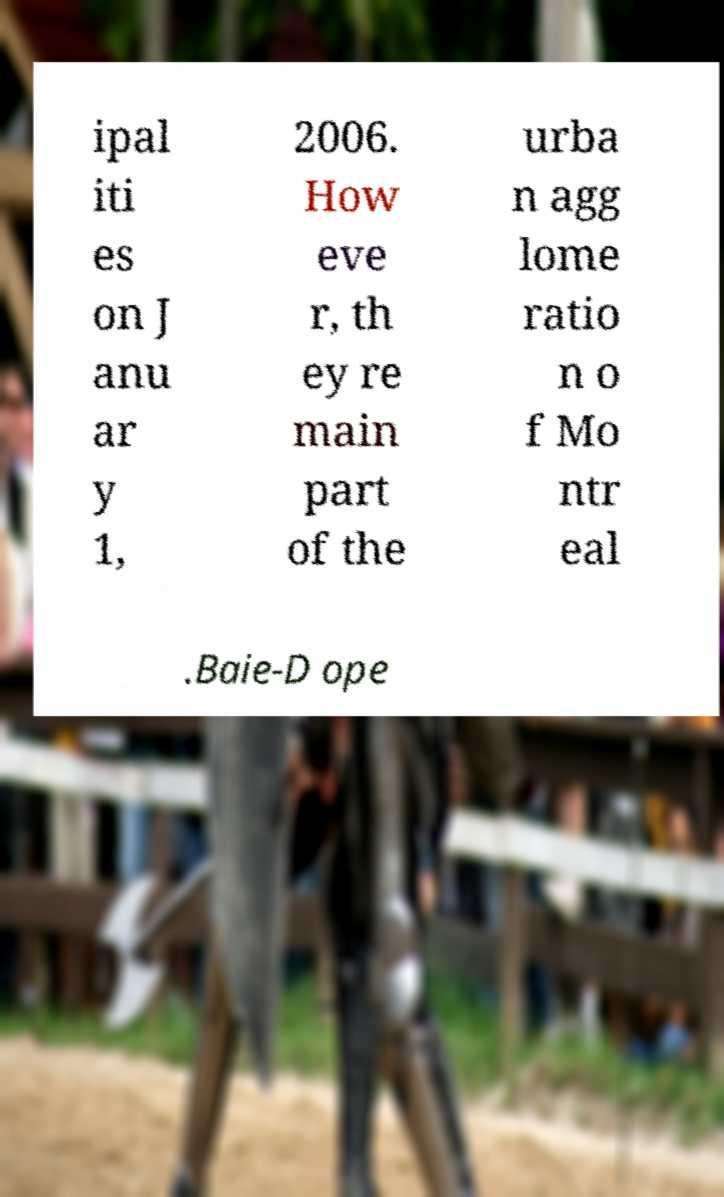For documentation purposes, I need the text within this image transcribed. Could you provide that? ipal iti es on J anu ar y 1, 2006. How eve r, th ey re main part of the urba n agg lome ratio n o f Mo ntr eal .Baie-D ope 